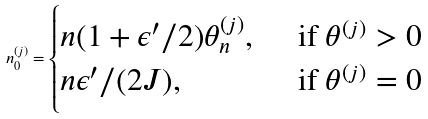Convert formula to latex. <formula><loc_0><loc_0><loc_500><loc_500>n _ { 0 } ^ { ( j ) } = \begin{cases} n ( 1 + \epsilon ^ { \prime } / 2 ) \theta _ { n } ^ { ( j ) } , \, & \text { if } \theta ^ { ( j ) } > 0 \\ n \epsilon ^ { \prime } / ( 2 J ) , & \text { if } \theta ^ { ( j ) } = 0 \end{cases}</formula> 